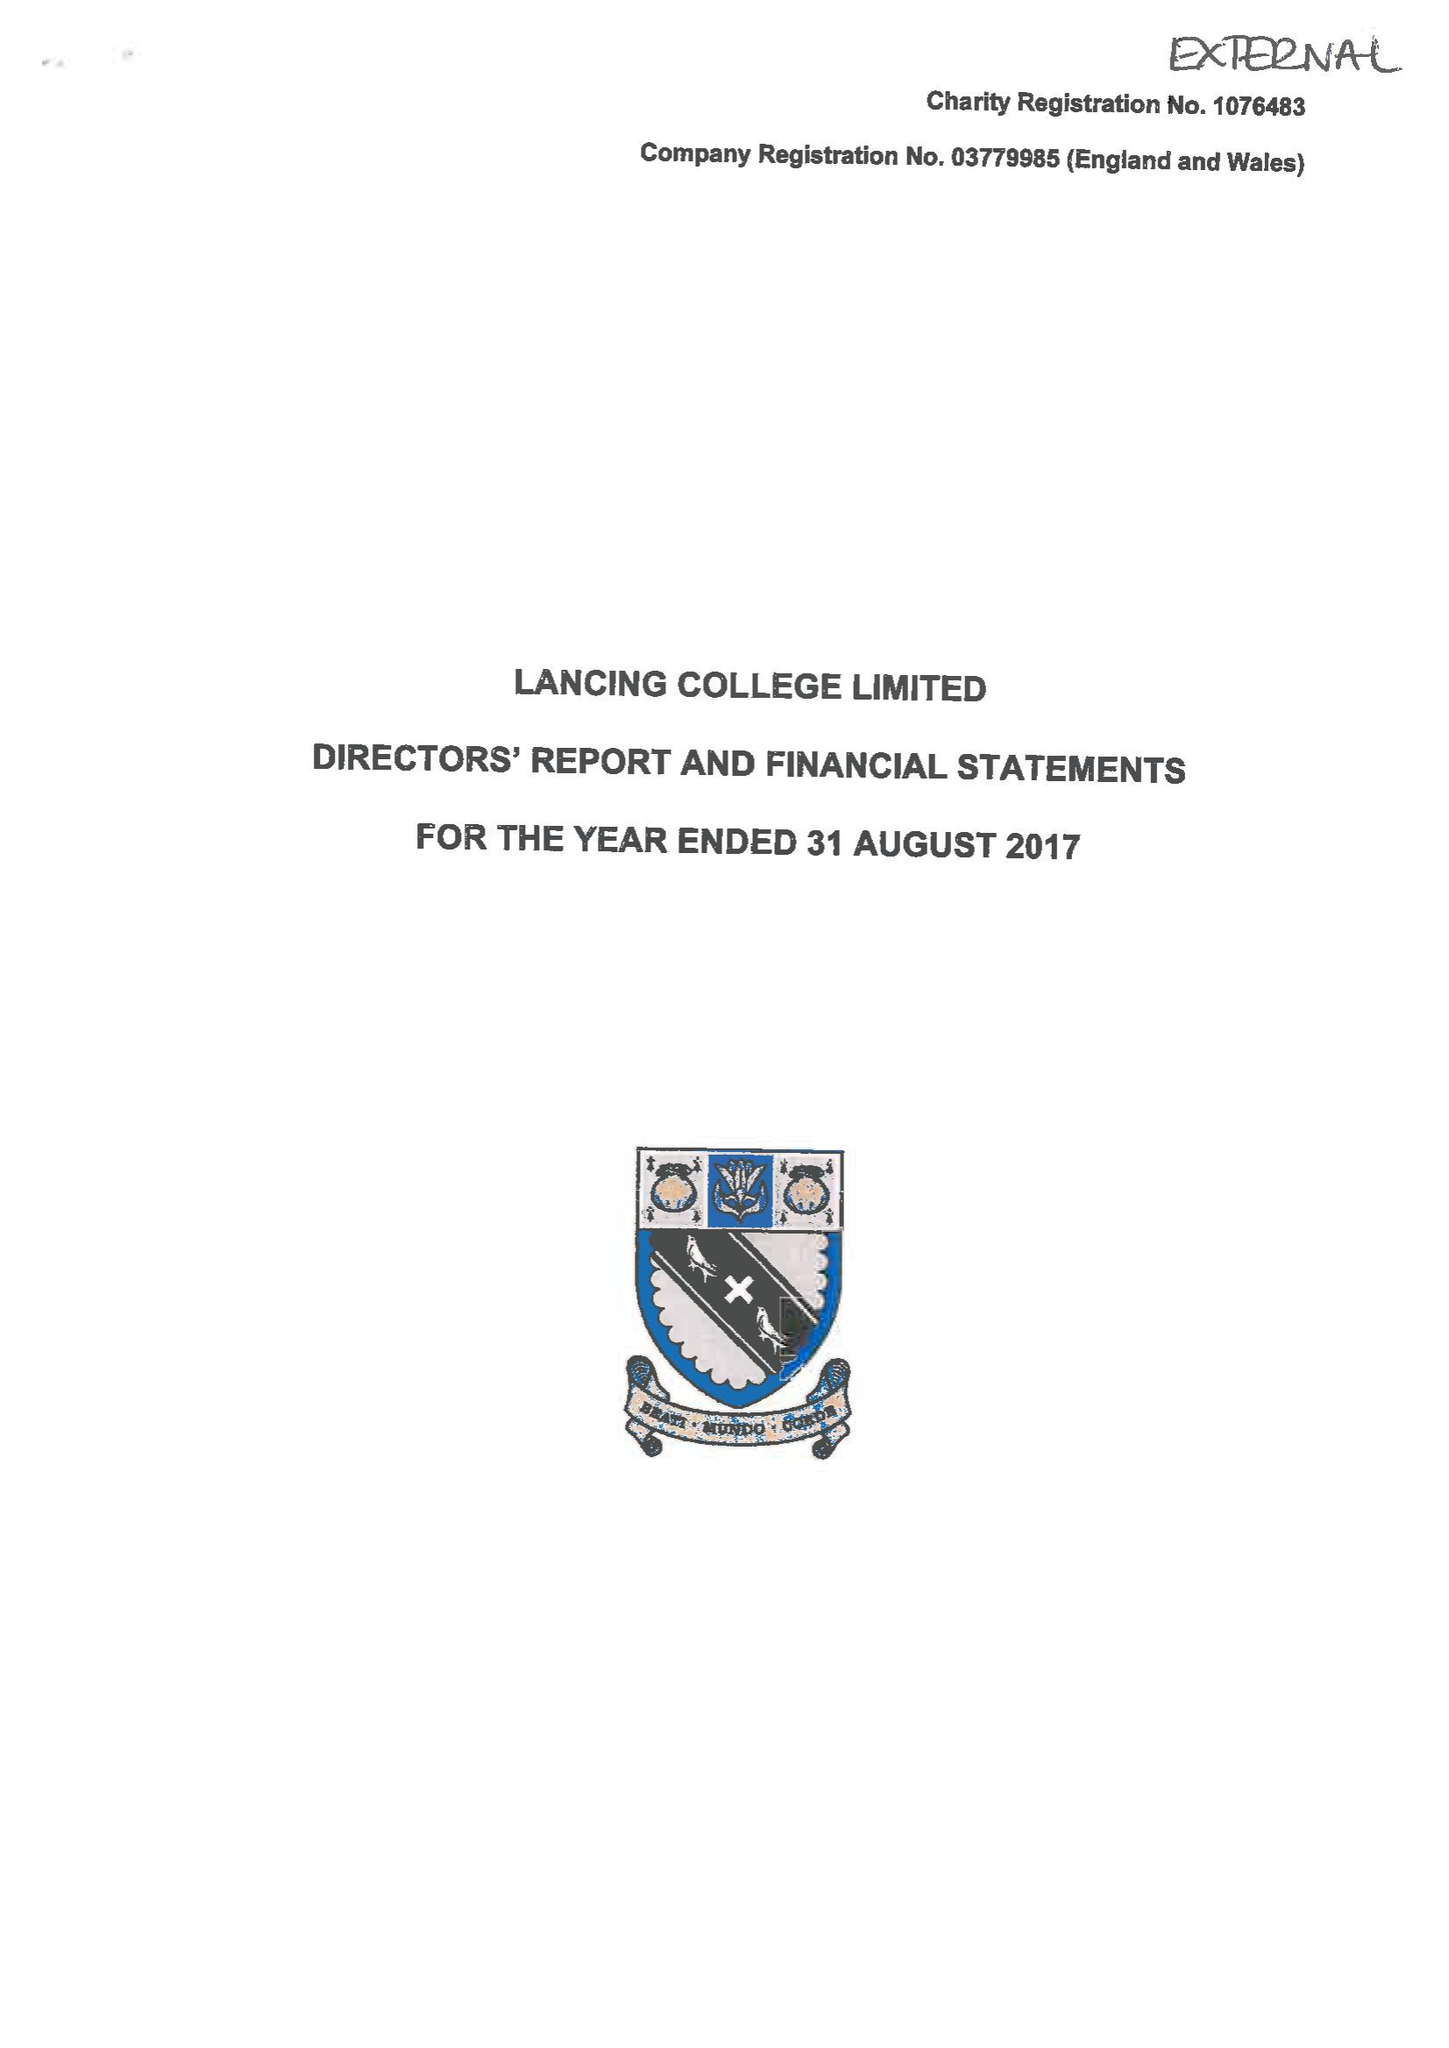What is the value for the spending_annually_in_british_pounds?
Answer the question using a single word or phrase. 20517046.00 